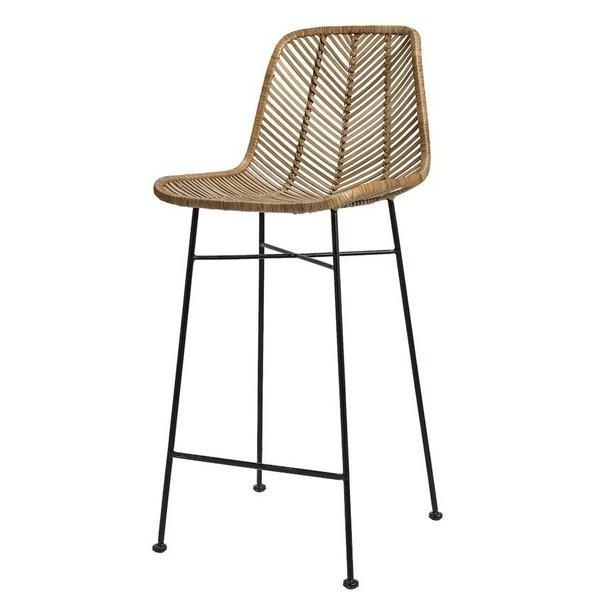Imagine this bar stool is actually a functional art piece that transforms into something else. What could it transform into, and how? This bar stool could transform into a functional art piece by turning into a freestanding floor lamp. The seat could lift up, revealing a hidden, retractable lamp inside. The woven material could open up like petals of a flower to spread light, creating an intricate pattern of shadows and highlights reminiscent of the weave. The legs of the stool, with an adjustable mechanism, could extend to raise the lamp to the desired height. The transformation could be activated by a motion sensor or a remote control, turning a simple piece of furniture into a dynamic, multifunctional art installation that provides illumination and aesthetic intrigue. 